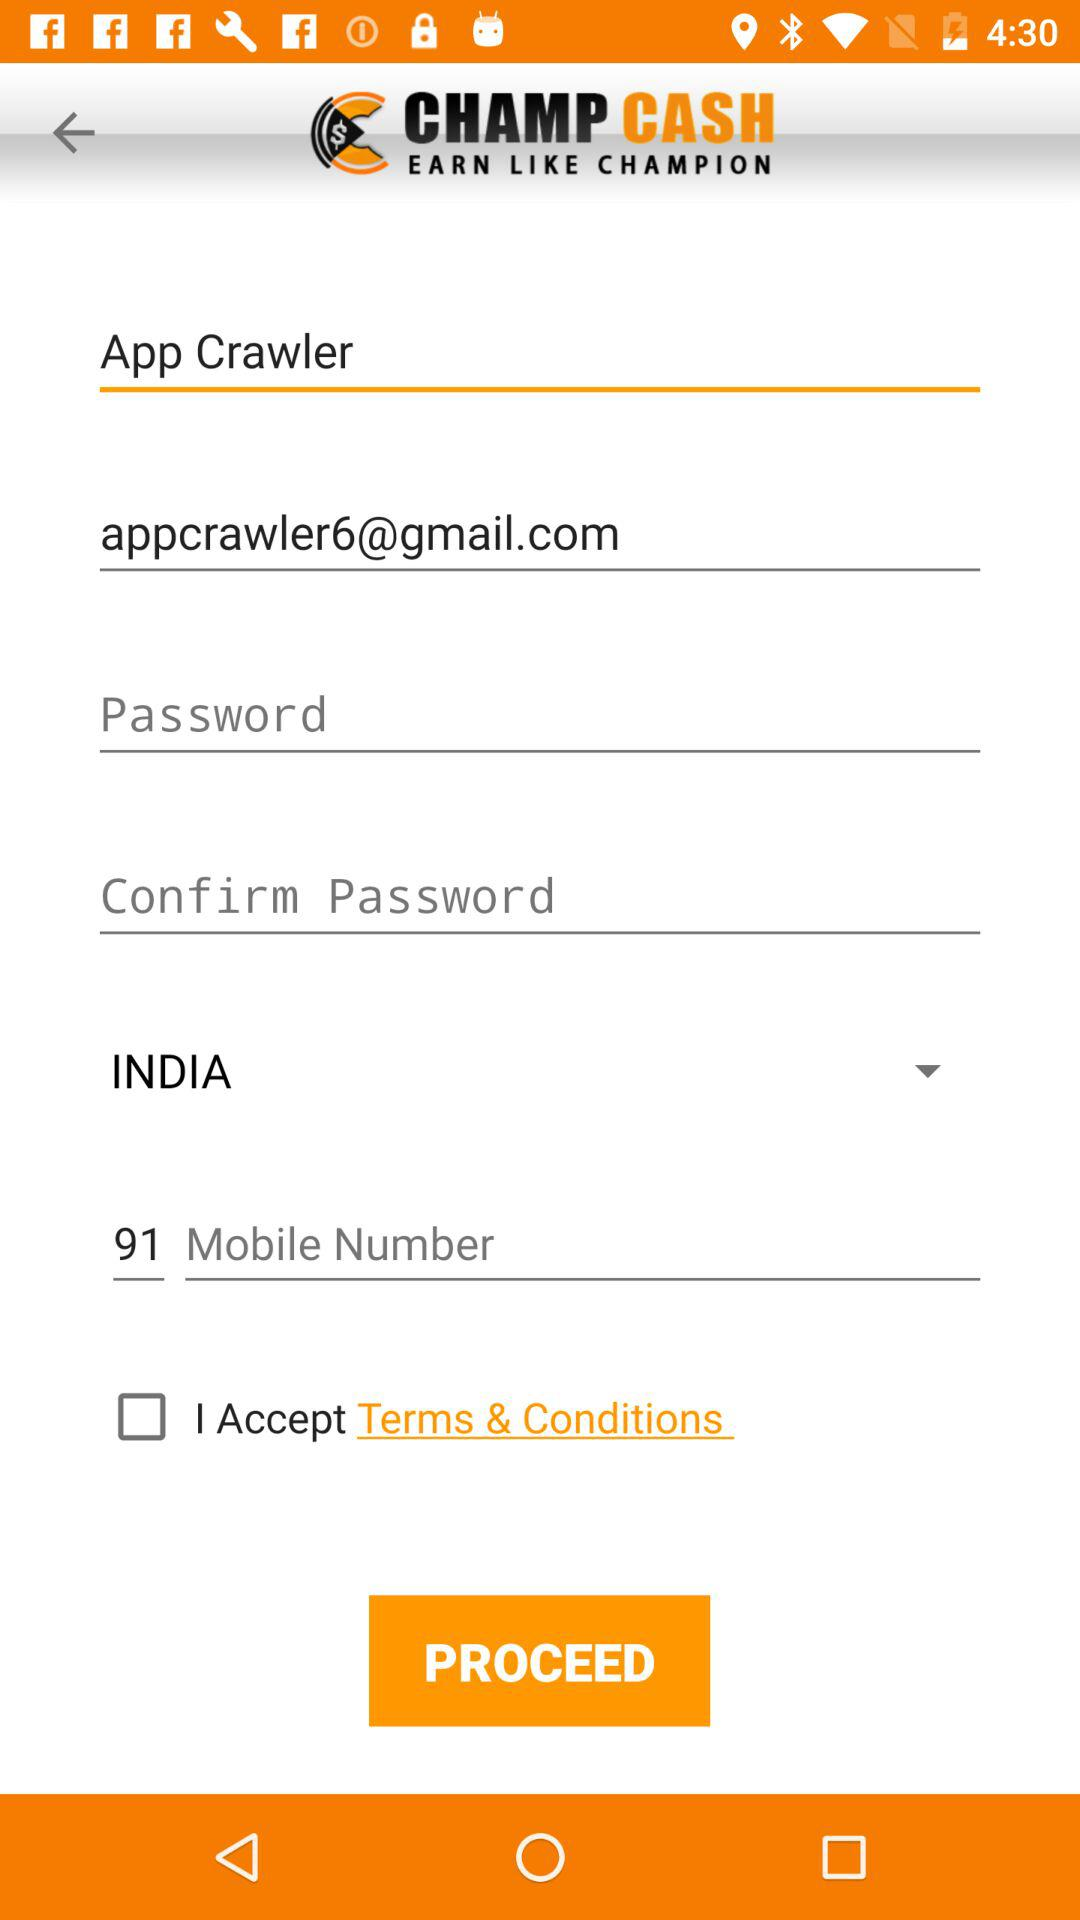What is the email address of the user? The email address of the user is appcrawler6@gmail.com. 